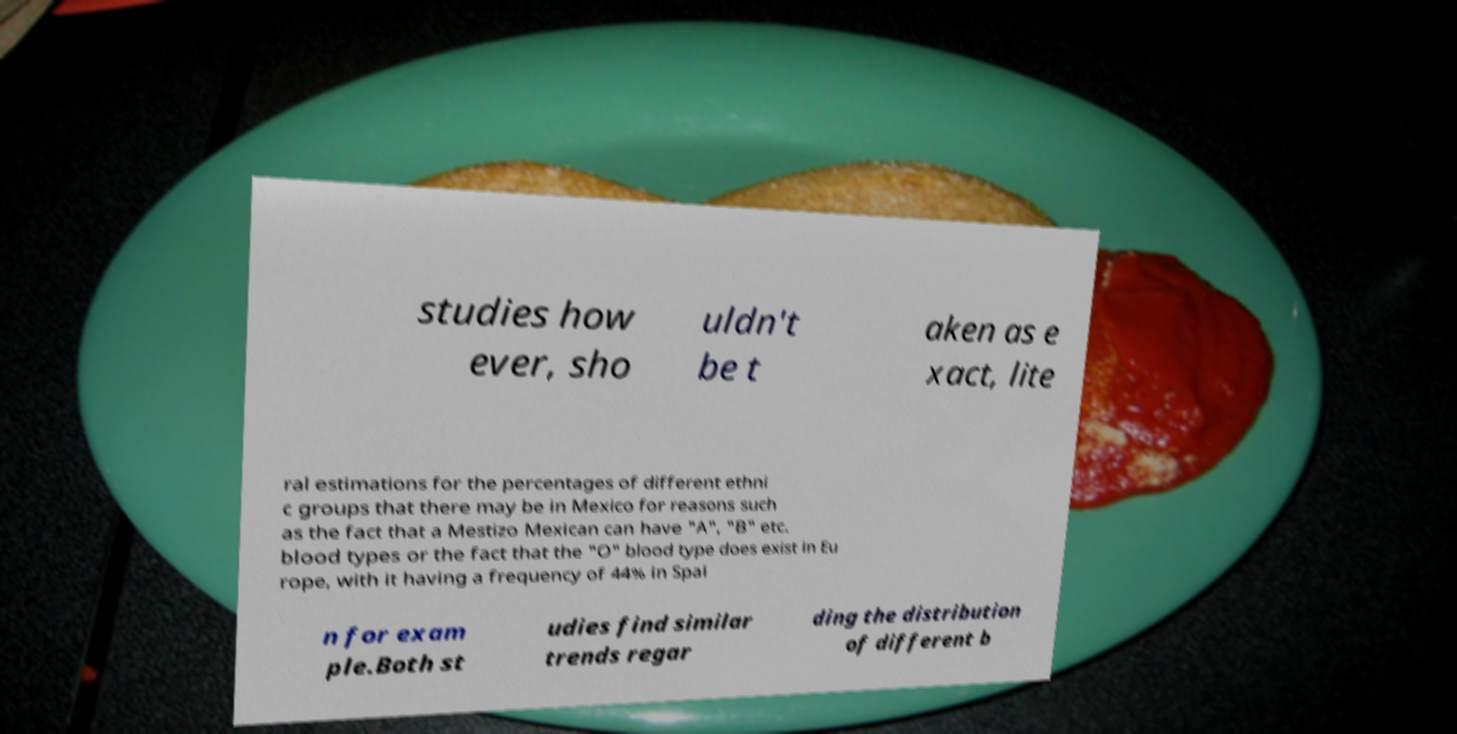I need the written content from this picture converted into text. Can you do that? studies how ever, sho uldn't be t aken as e xact, lite ral estimations for the percentages of different ethni c groups that there may be in Mexico for reasons such as the fact that a Mestizo Mexican can have "A", "B" etc. blood types or the fact that the "O" blood type does exist in Eu rope, with it having a frequency of 44% in Spai n for exam ple.Both st udies find similar trends regar ding the distribution of different b 